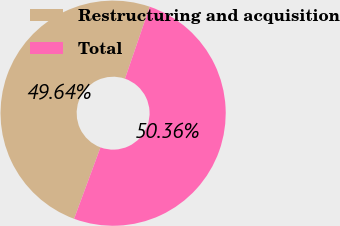Convert chart. <chart><loc_0><loc_0><loc_500><loc_500><pie_chart><fcel>Restructuring and acquisition<fcel>Total<nl><fcel>49.64%<fcel>50.36%<nl></chart> 